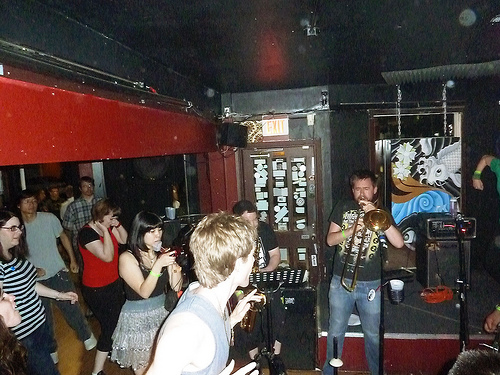<image>
Can you confirm if the red shirt is on the guy? No. The red shirt is not positioned on the guy. They may be near each other, but the red shirt is not supported by or resting on top of the guy. Is there a men behind the women? No. The men is not behind the women. From this viewpoint, the men appears to be positioned elsewhere in the scene. 